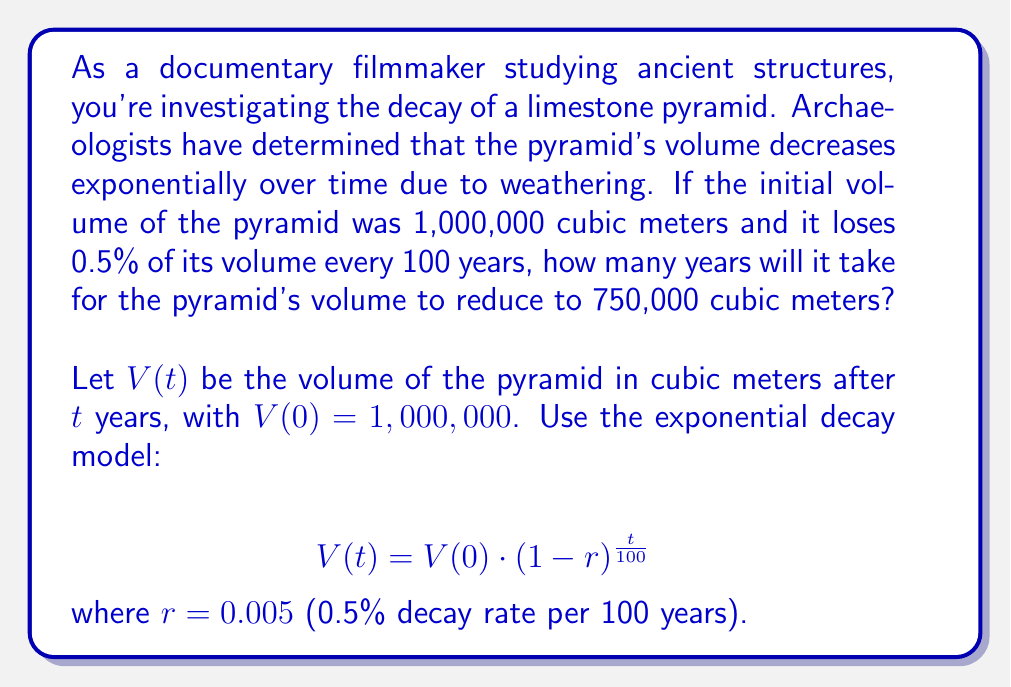Teach me how to tackle this problem. To solve this problem, we'll use the exponential decay model and follow these steps:

1) First, let's write out our equation with the given values:
   $$750,000 = 1,000,000 \cdot (1 - 0.005)^{\frac{t}{100}}$$

2) Simplify the right side:
   $$750,000 = 1,000,000 \cdot (0.995)^{\frac{t}{100}}$$

3) Divide both sides by 1,000,000:
   $$0.75 = (0.995)^{\frac{t}{100}}$$

4) Take the natural logarithm of both sides:
   $$\ln(0.75) = \ln((0.995)^{\frac{t}{100}})$$

5) Use the logarithm property $\ln(a^b) = b\ln(a)$:
   $$\ln(0.75) = \frac{t}{100} \cdot \ln(0.995)$$

6) Multiply both sides by 100:
   $$100 \cdot \ln(0.75) = t \cdot \ln(0.995)$$

7) Divide both sides by $\ln(0.995)$:
   $$t = \frac{100 \cdot \ln(0.75)}{\ln(0.995)}$$

8) Calculate the result:
   $$t \approx 5729.98 \text{ years}$$

9) Round to the nearest year:
   $$t \approx 5730 \text{ years}$$
Answer: 5730 years 